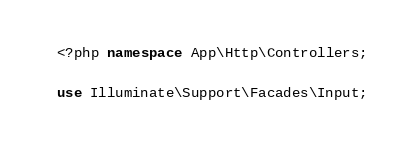Convert code to text. <code><loc_0><loc_0><loc_500><loc_500><_PHP_><?php namespace App\Http\Controllers;

use Illuminate\Support\Facades\Input;</code> 